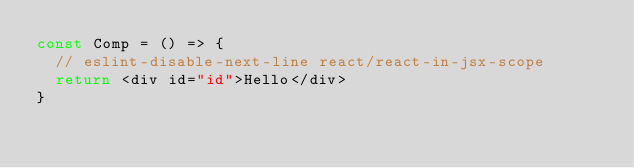Convert code to text. <code><loc_0><loc_0><loc_500><loc_500><_TypeScript_>const Comp = () => {
  // eslint-disable-next-line react/react-in-jsx-scope
  return <div id="id">Hello</div>
}
</code> 